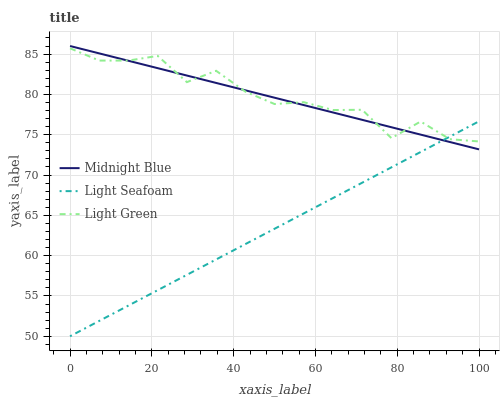Does Midnight Blue have the minimum area under the curve?
Answer yes or no. No. Does Midnight Blue have the maximum area under the curve?
Answer yes or no. No. Is Light Green the smoothest?
Answer yes or no. No. Is Midnight Blue the roughest?
Answer yes or no. No. Does Midnight Blue have the lowest value?
Answer yes or no. No. Does Light Green have the highest value?
Answer yes or no. No. 